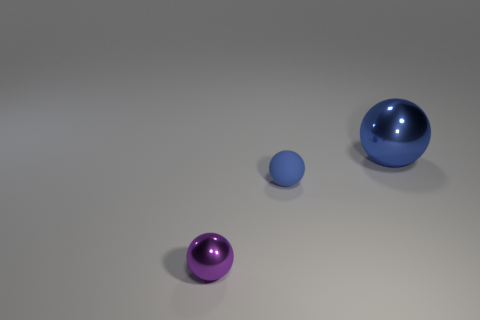What is the color of the small thing in front of the matte object? The color of the smaller sphere located in front of the larger, matte sphere is a soft shade of blue. 